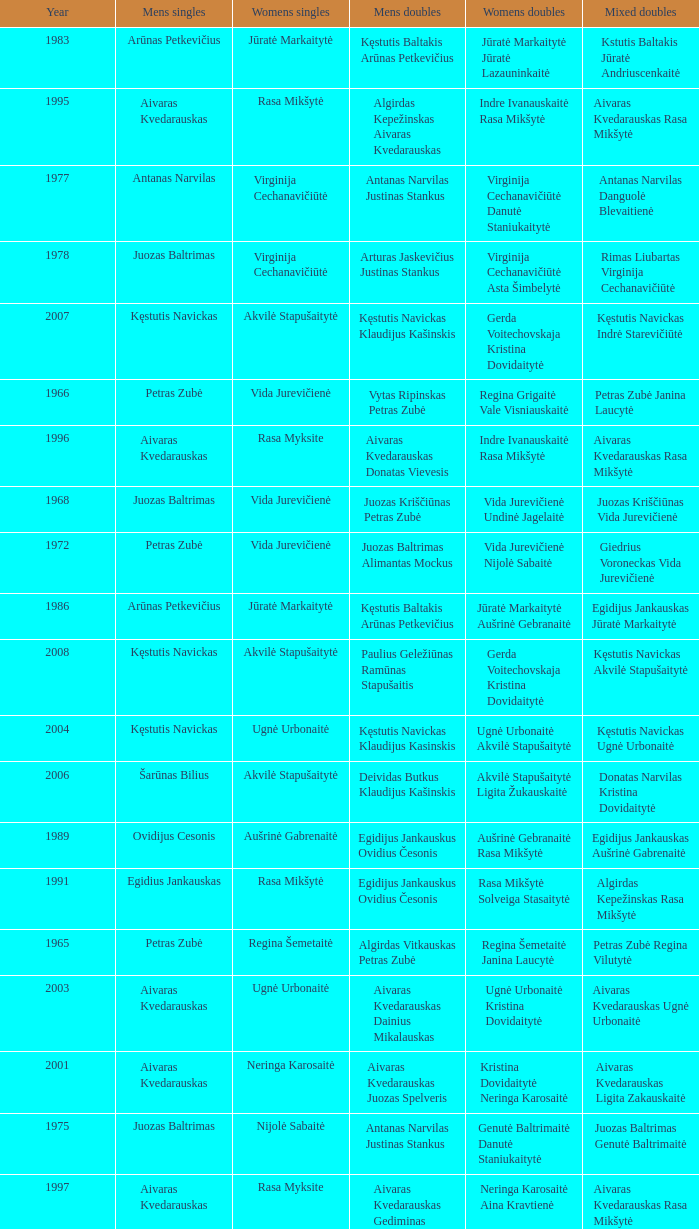What was the first year of the Lithuanian National Badminton Championships? 1963.0. 